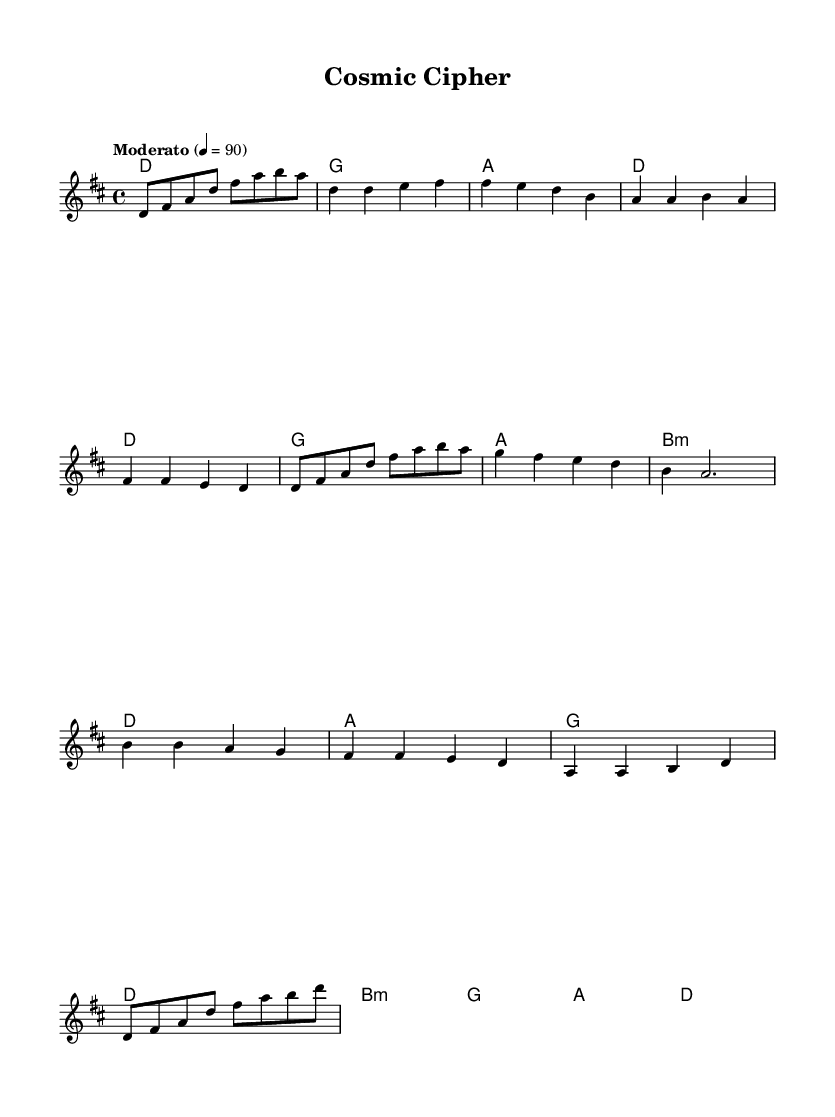What is the key signature of this music? The key signature is D major, which has two sharps (F# and C#). This can be identified by looking at the key signature section noted at the beginning of the score.
Answer: D major What is the time signature of this piece? The time signature indicated in the music is 4/4, meaning there are four beats in each measure and the quarter note receives one beat. This is written at the beginning of the score right after the key signature.
Answer: 4/4 What is the tempo marking of this piece? The tempo marking provided states "Moderato" with a metronome marking of quarter note = 90. This indicates a moderate pace, typically understood in common practice music.
Answer: Moderato, 90 What chord is played during the bridge section? In the bridge section, the first chord indicated is B minor, which is denoted as "b:m" under the chord changes in the score. This suggests the harmonic context for that part of the music.
Answer: B minor How many measures are in the chorus? The chorus consists of four measures, which can be counted by examining the music and identifying the number of distinct bar lines.
Answer: 4 What is the starting note of the melody? The starting note of the melody is D, which is visible at the beginning of the melody line in the score. It is the first note played in the introductory section.
Answer: D How many distinct sections are present in this music? There are four distinct sections in the piece: Intro, Verse, Chorus, and Bridge. This can be inferred from the structure outlined in the score's formatting and the different music phrases represented.
Answer: 4 